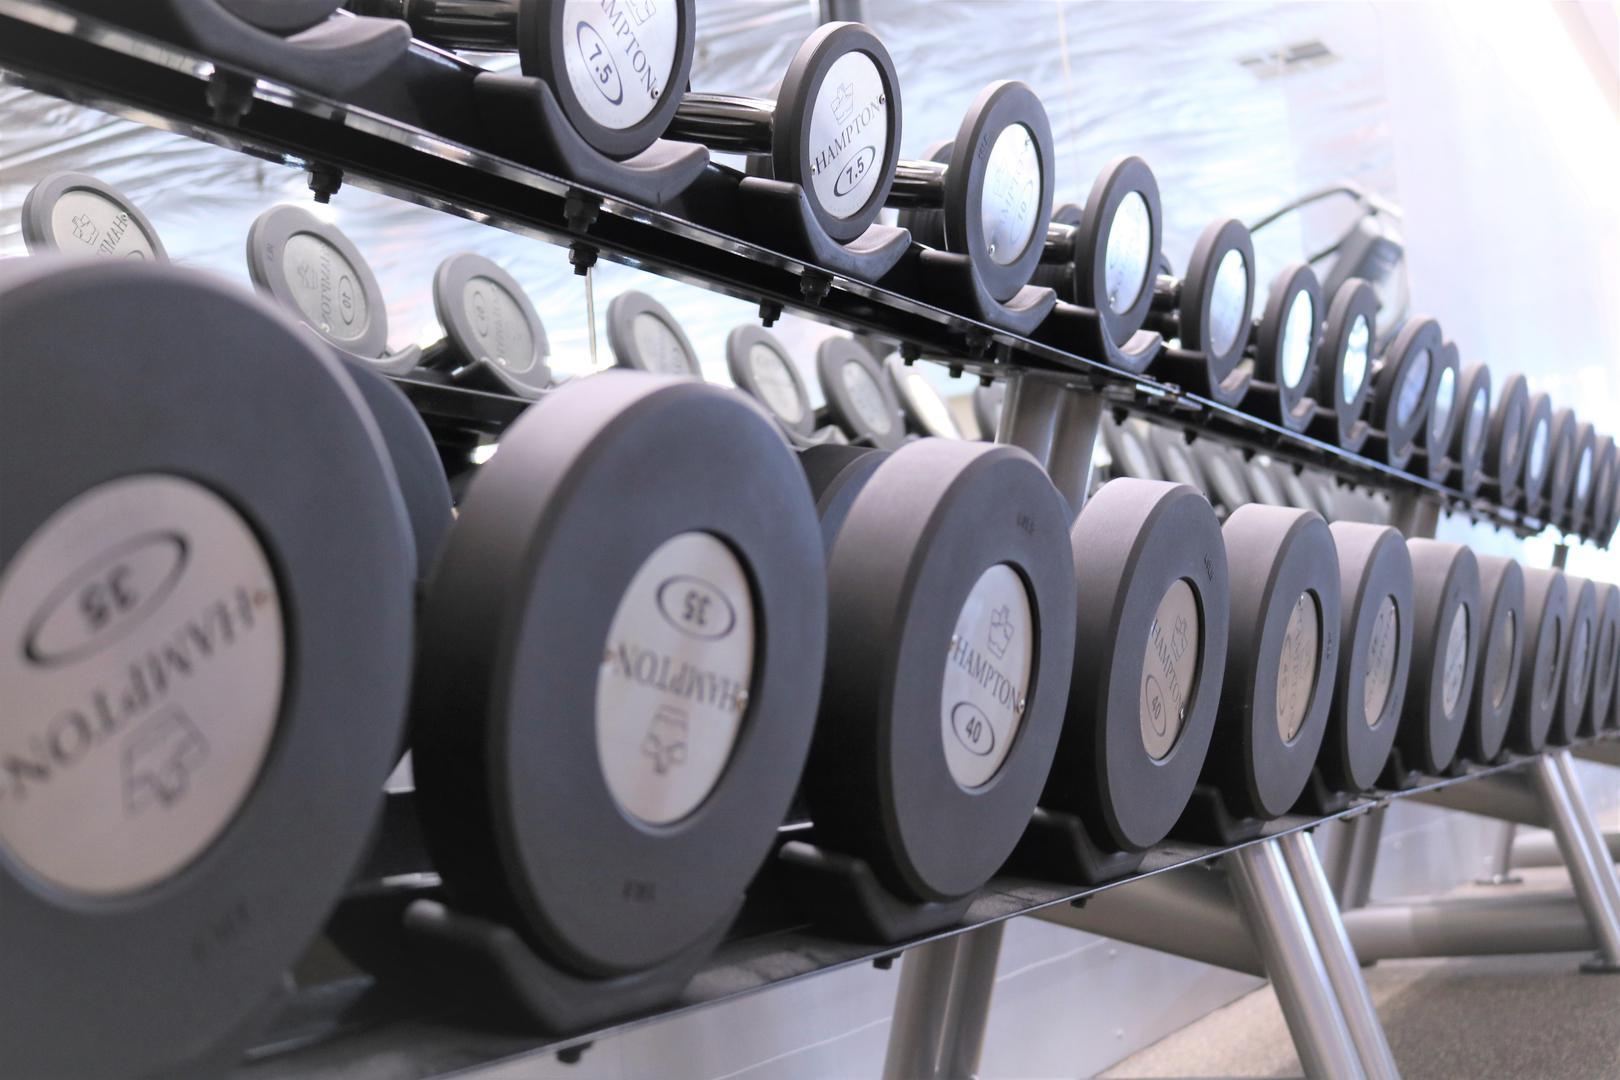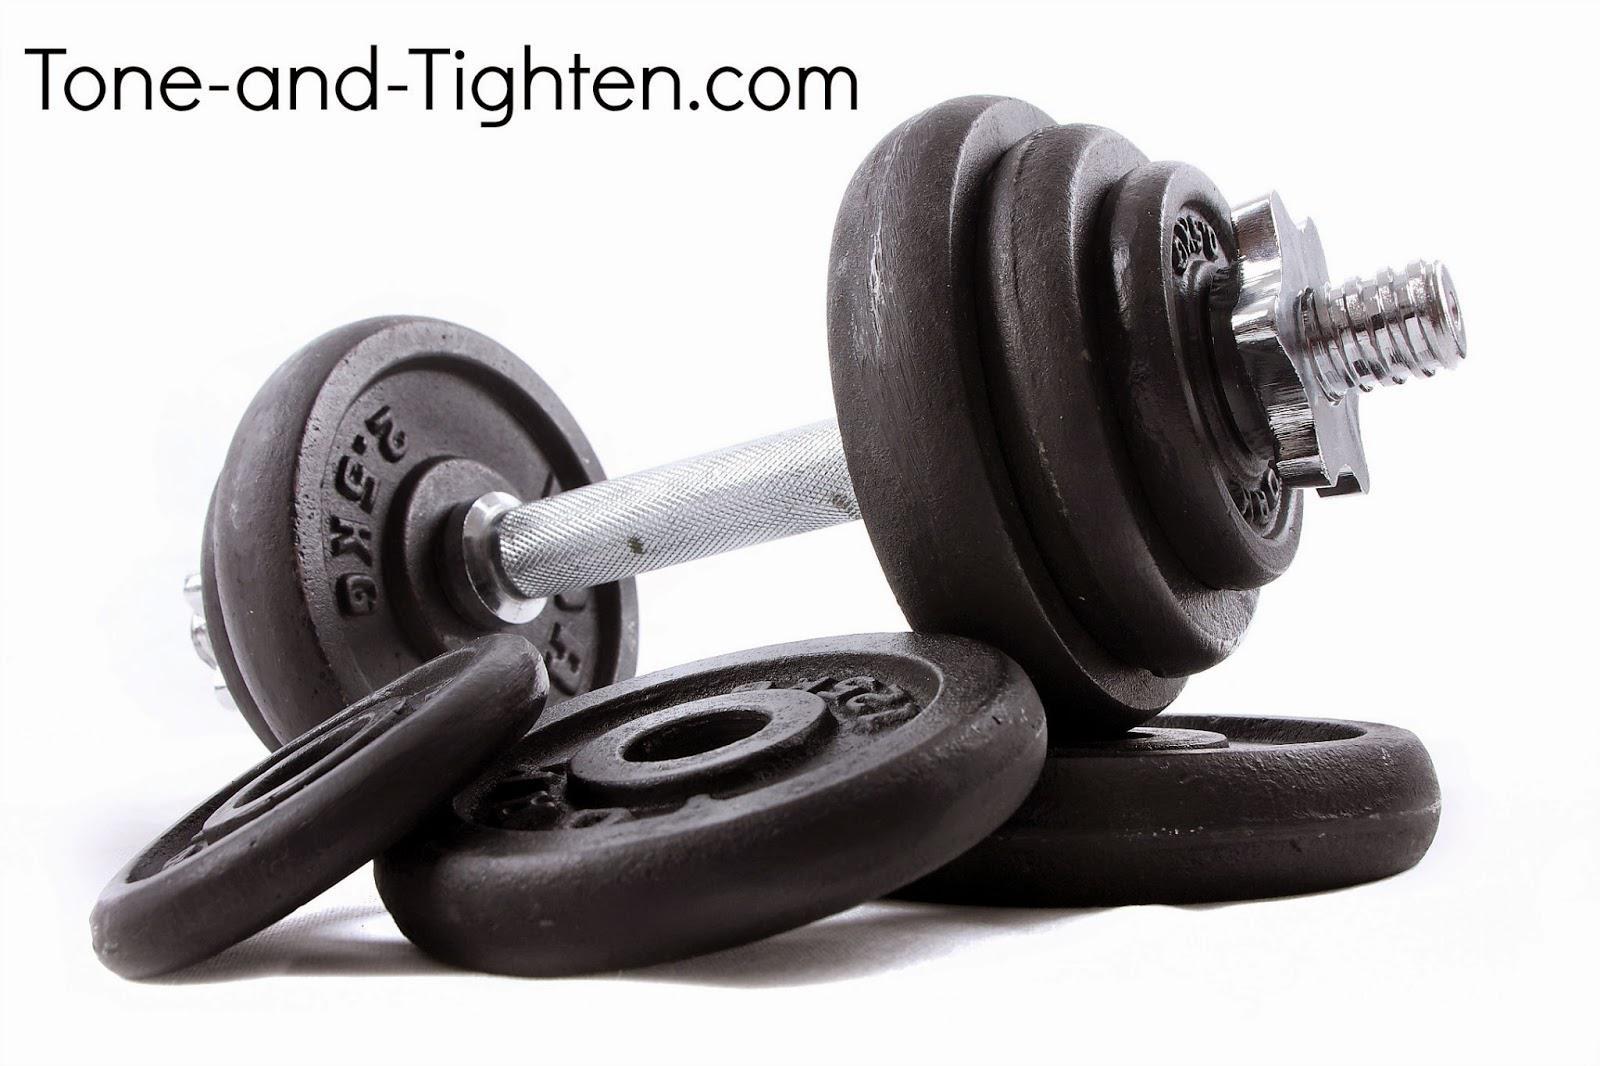The first image is the image on the left, the second image is the image on the right. For the images shown, is this caption "In one of the images, there is an assembled dumbbell with extra plates next to it." true? Answer yes or no. Yes. The first image is the image on the left, the second image is the image on the right. For the images shown, is this caption "One image shows a row of at least four black barbells on a black rack." true? Answer yes or no. Yes. 